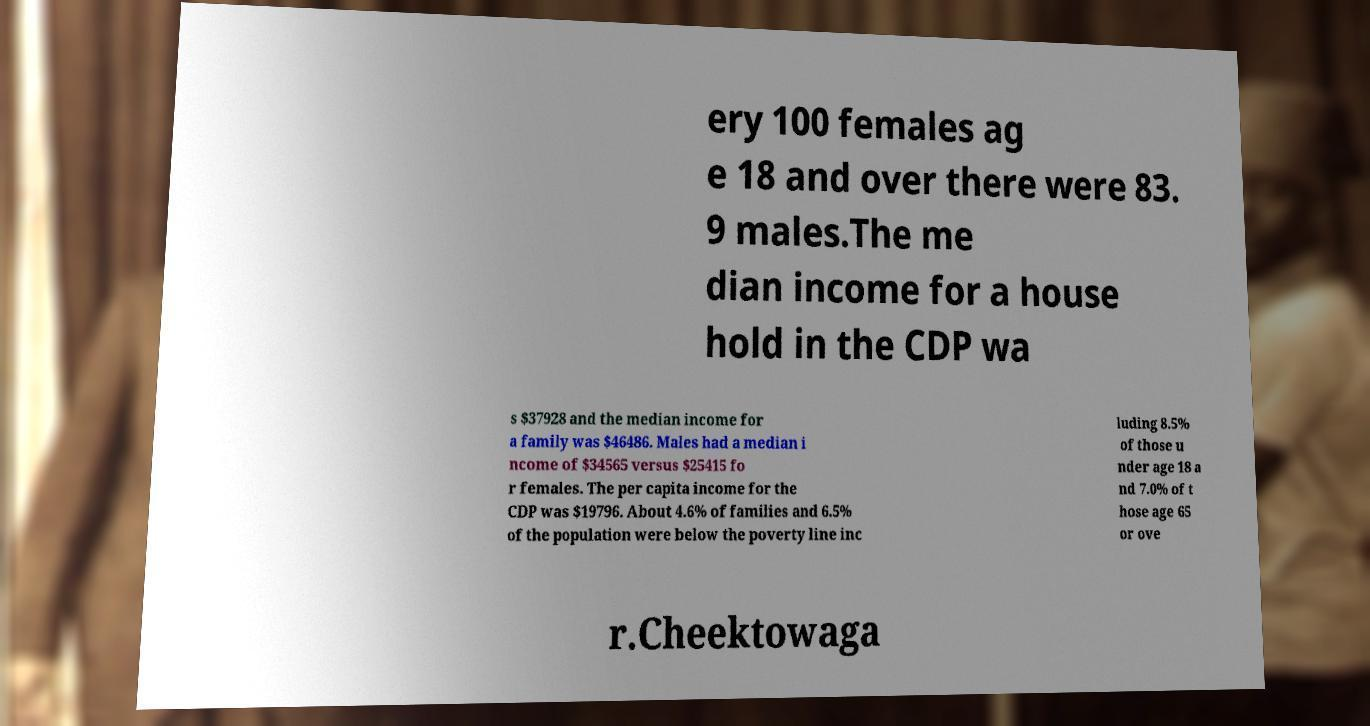Could you extract and type out the text from this image? ery 100 females ag e 18 and over there were 83. 9 males.The me dian income for a house hold in the CDP wa s $37928 and the median income for a family was $46486. Males had a median i ncome of $34565 versus $25415 fo r females. The per capita income for the CDP was $19796. About 4.6% of families and 6.5% of the population were below the poverty line inc luding 8.5% of those u nder age 18 a nd 7.0% of t hose age 65 or ove r.Cheektowaga 